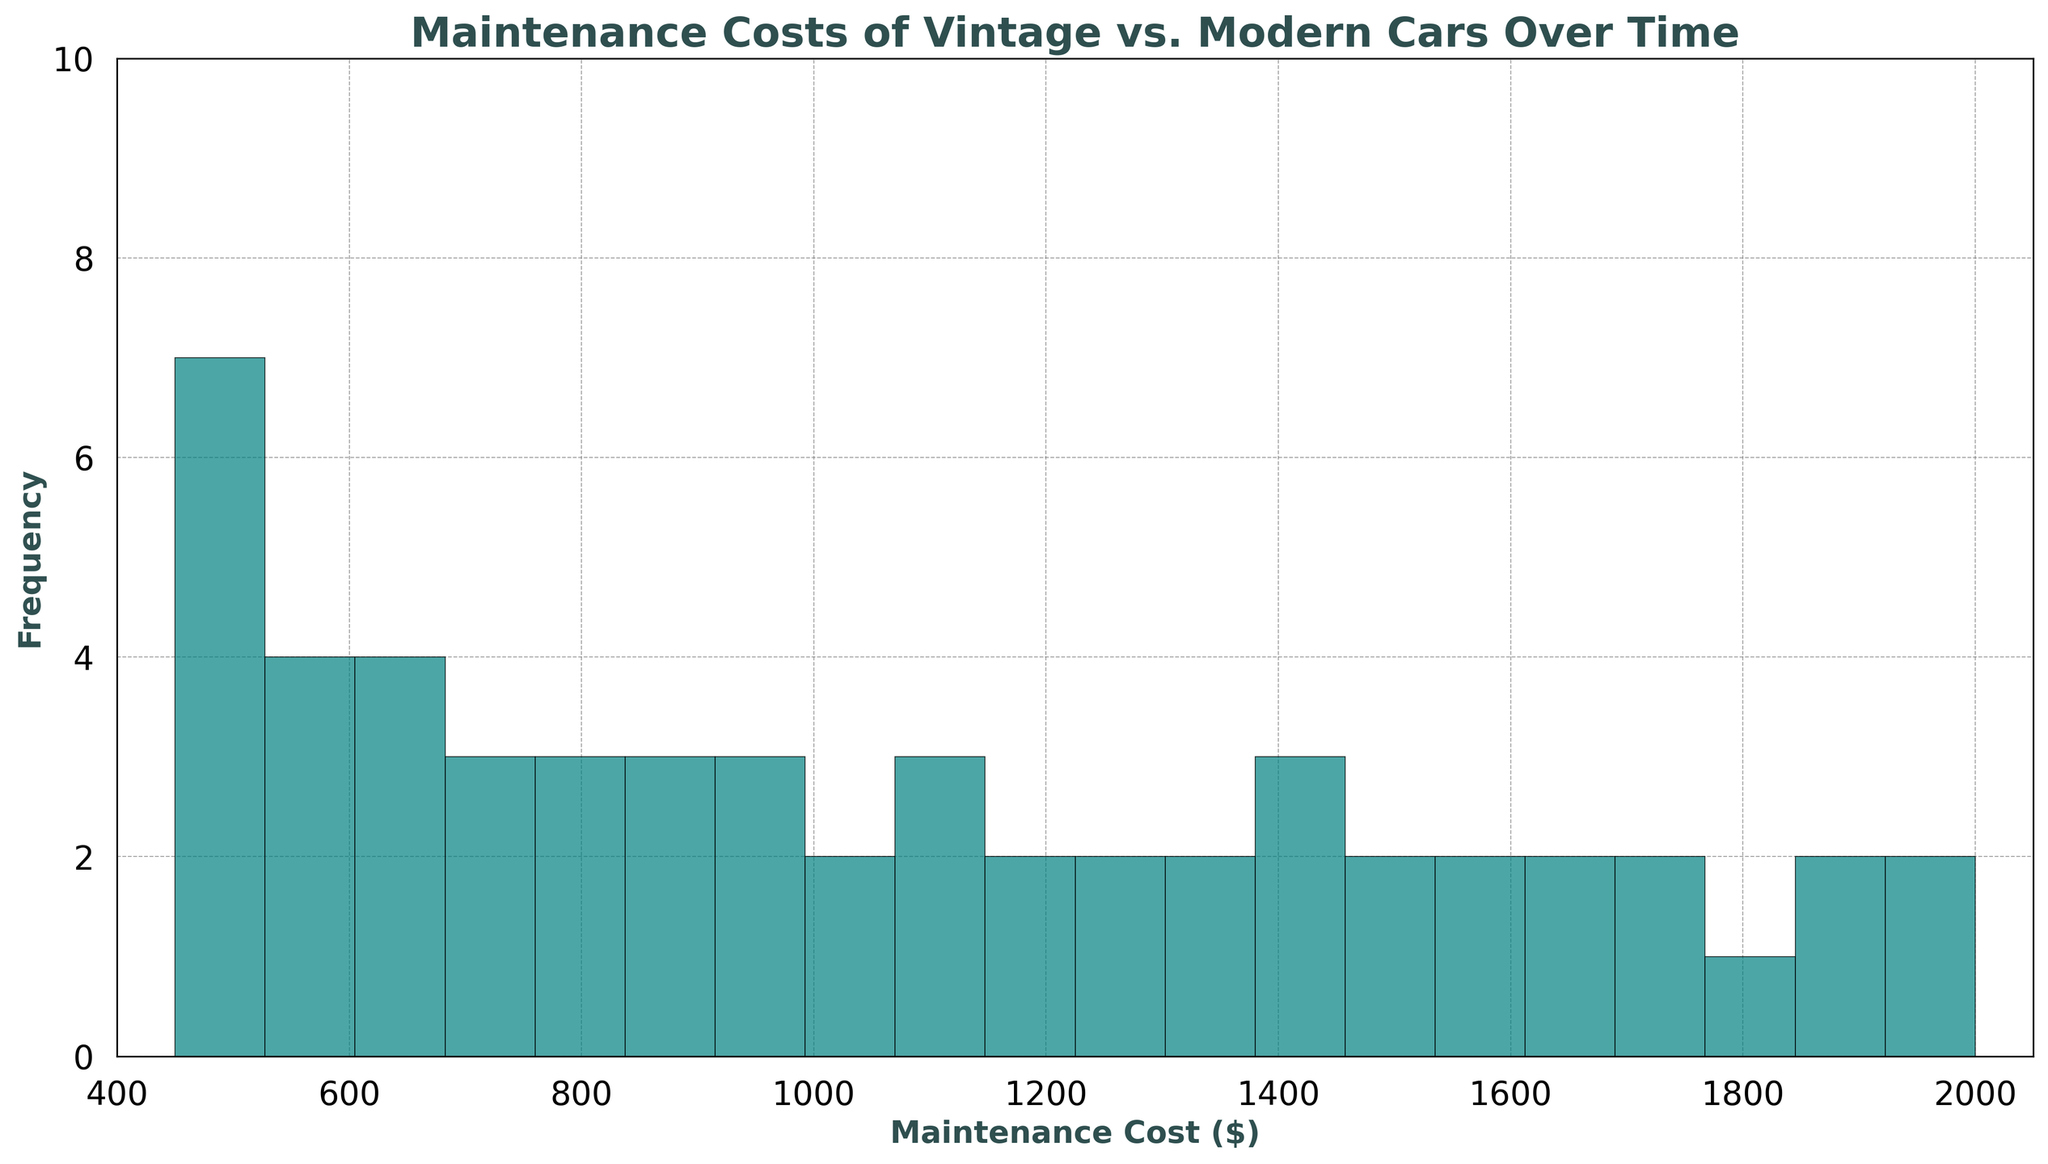What year does the histogram data start? The x-axis shows Maintenance Cost, not the year directly. However, based on the data provided, the earliest year is 1970.
Answer: 1970 What is the approximate range of Maintenance Costs depicted in the chart? The histogram's x-axis ranges from a bit below the minimum Maintenance Cost (450) to a bit above the maximum Maintenance Cost (2000). Therefore, the approximate range is from around 400 to 2050.
Answer: 400 to 2050 How does the frequency of lower maintenance costs compare with higher maintenance costs? The histogram likely shows more bars with higher frequencies at lower Maintenance Costs, suggesting that lower maintenance costs occur more frequently than higher ones.
Answer: Lower costs occur more frequently Which Maintenance Cost has the highest frequency in the histogram? To determine this, look for the highest bar in the histogram. The specific value would be at the x-axis below this bar. Without the actual figure, we can't pinpoint the exact value, but it's usually one of the lower Maintenance Costs.
Answer: One of the lower Maintenance Costs What is the median Maintenance Cost value observed in the histogram? To find the median, one would look for the central value where half the data points are below and half above. The middle year being around 1996.5, this Value is halfway between 960 and 990, hence it is 975.
Answer: 975 Which portion of the histogram displays more variation, the earlier years (vintage cars) or the later years (modern cars)? The histogram's spread and bar heights will indicate this. Typically, modern cars (later years) will show wider variation and higher costs, reflected in a spread-out pattern.
Answer: Modern cars What is the main difference in the frequency distribution of maintenance costs between vintage and modern cars? Vintage cars (earlier years) will likely show a concentration of lower maintenance costs with higher frequency, whereas modern cars (later years) will show higher costs with possibly lower individual frequencies.
Answer: Vintage cars have lower costs with higher frequency How does the increase in maintenance cost over time appear in the histogram? The histogram would show an increasing trend, with bars gradually shifting to the right (indicating higher costs) as time progresses from vintage to modern cars.
Answer: Increasing trend over time What is the highest value of Maintenance Cost shown in the histogram? Check the right end of the x-axis to find the maximum value indicated. According to the data, this would be 2000.
Answer: 2000 How evenly are the maintenance costs distributed over the 20 different bins? This involves analyzing the height of bars across all bins. If bars are of similar height, the distribution is even; otherwise, it is uneven. Based on typical maintenance costs distribution, you'd expect an uneven distribution with more frequent lower costs.
Answer: Uneven distribution 